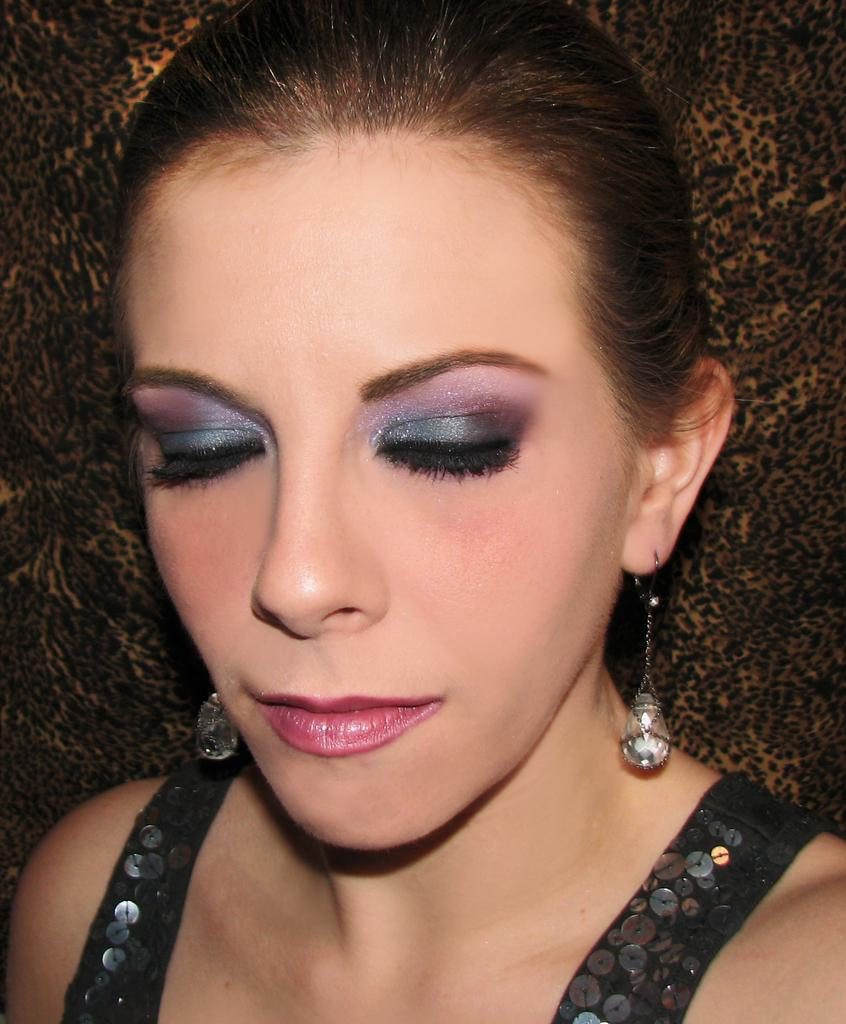Who is the main subject in the image? There is a lady in the image. What can be seen in the background of the image? There is a cloth in the background of the image. What type of attention does the lady receive from the side in the image? There is no indication in the image that the lady is receiving any specific type of attention from the side. 